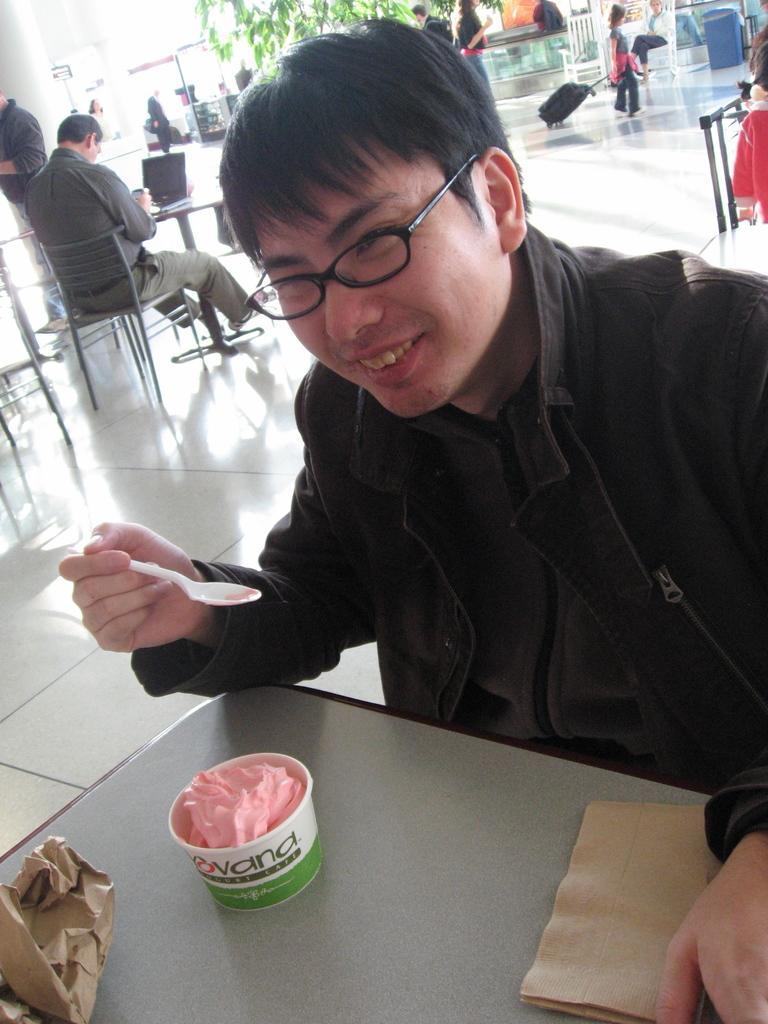How would you summarize this image in a sentence or two? In this image we can see a person is sitting on a chair and eating ice cream. 